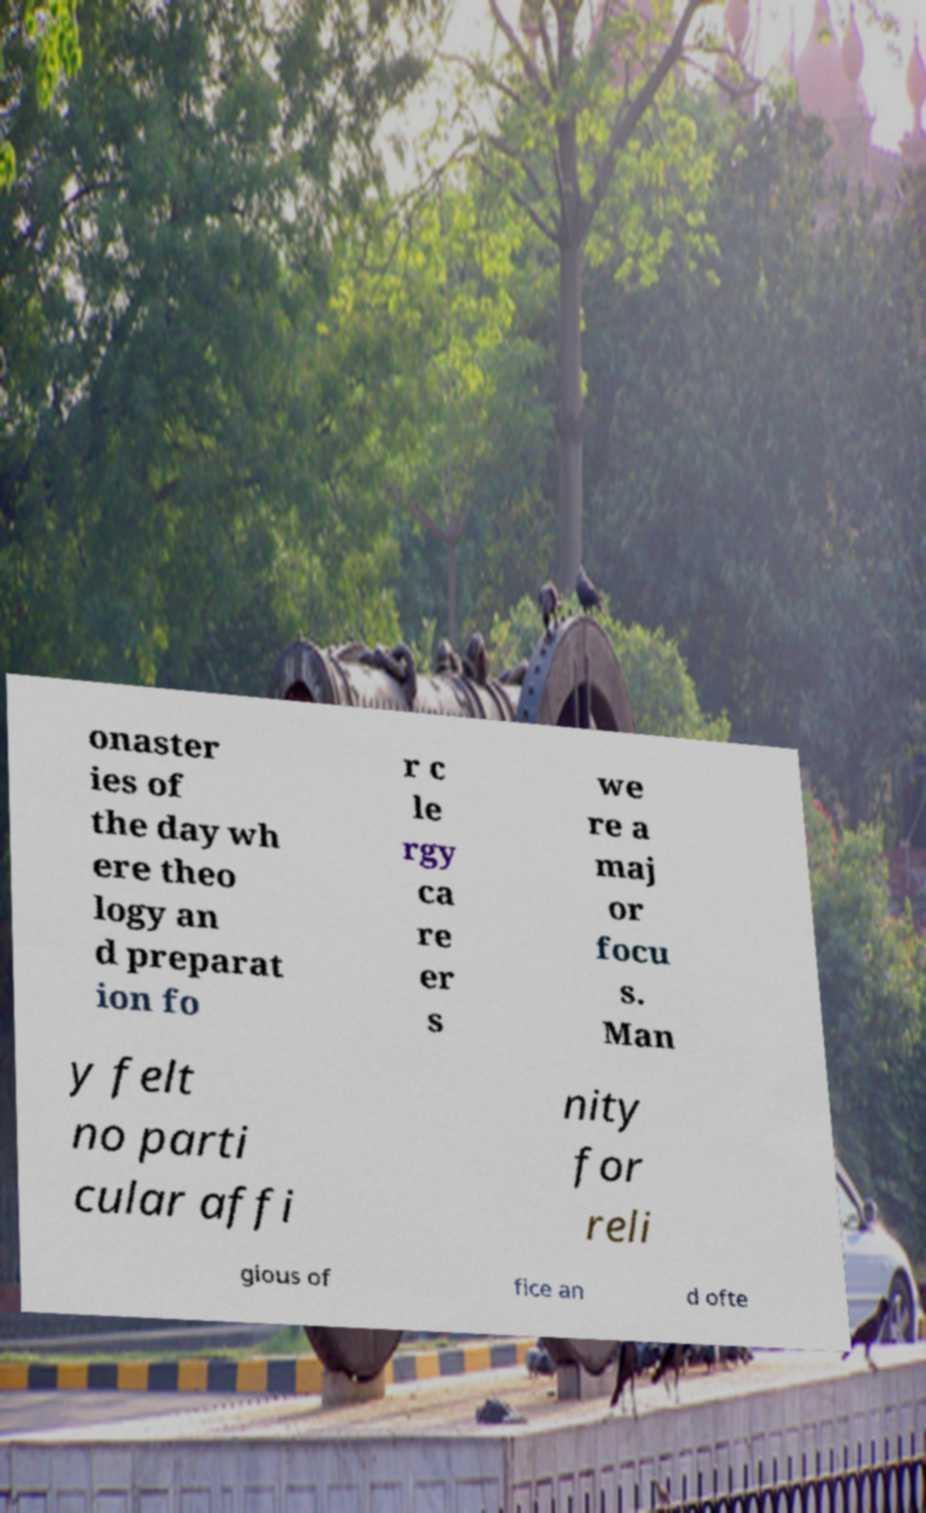Could you assist in decoding the text presented in this image and type it out clearly? onaster ies of the day wh ere theo logy an d preparat ion fo r c le rgy ca re er s we re a maj or focu s. Man y felt no parti cular affi nity for reli gious of fice an d ofte 